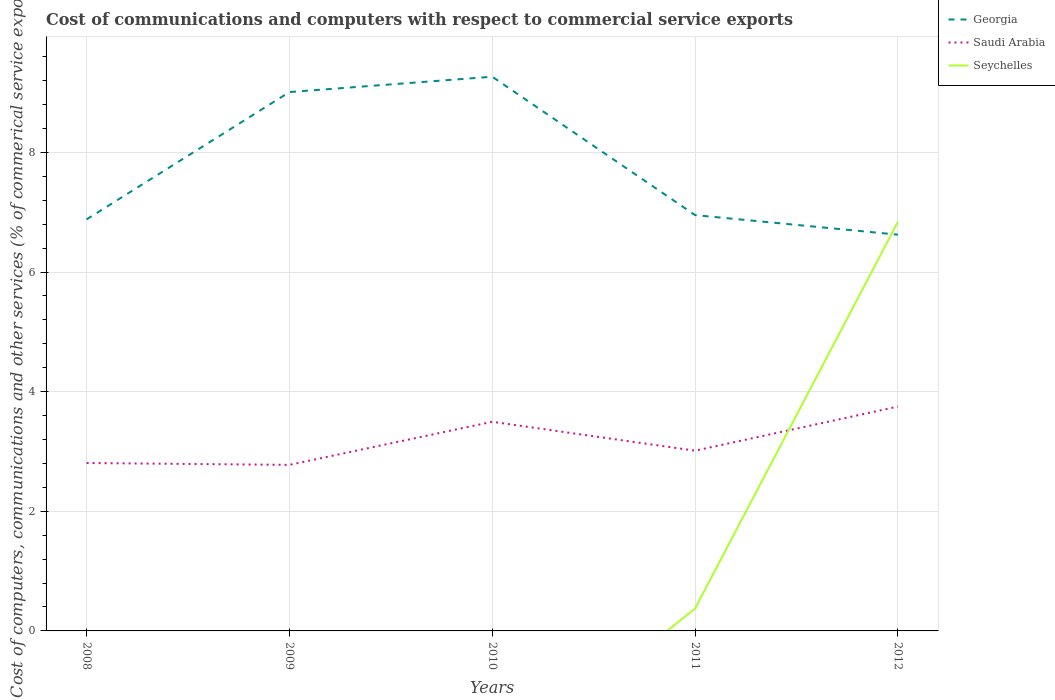How many different coloured lines are there?
Offer a very short reply. 3. Does the line corresponding to Georgia intersect with the line corresponding to Seychelles?
Make the answer very short. Yes. Is the number of lines equal to the number of legend labels?
Provide a short and direct response. No. What is the total cost of communications and computers in Georgia in the graph?
Ensure brevity in your answer.  -0.26. What is the difference between the highest and the second highest cost of communications and computers in Georgia?
Make the answer very short. 2.64. What is the difference between two consecutive major ticks on the Y-axis?
Make the answer very short. 2. Are the values on the major ticks of Y-axis written in scientific E-notation?
Make the answer very short. No. How many legend labels are there?
Provide a short and direct response. 3. How are the legend labels stacked?
Your response must be concise. Vertical. What is the title of the graph?
Your response must be concise. Cost of communications and computers with respect to commercial service exports. Does "Norway" appear as one of the legend labels in the graph?
Your answer should be compact. No. What is the label or title of the X-axis?
Keep it short and to the point. Years. What is the label or title of the Y-axis?
Make the answer very short. Cost of computers, communications and other services (% of commerical service exports). What is the Cost of computers, communications and other services (% of commerical service exports) of Georgia in 2008?
Make the answer very short. 6.88. What is the Cost of computers, communications and other services (% of commerical service exports) of Saudi Arabia in 2008?
Provide a short and direct response. 2.81. What is the Cost of computers, communications and other services (% of commerical service exports) in Georgia in 2009?
Provide a short and direct response. 9.01. What is the Cost of computers, communications and other services (% of commerical service exports) of Saudi Arabia in 2009?
Provide a short and direct response. 2.78. What is the Cost of computers, communications and other services (% of commerical service exports) in Seychelles in 2009?
Give a very brief answer. 0. What is the Cost of computers, communications and other services (% of commerical service exports) in Georgia in 2010?
Make the answer very short. 9.27. What is the Cost of computers, communications and other services (% of commerical service exports) of Saudi Arabia in 2010?
Ensure brevity in your answer.  3.5. What is the Cost of computers, communications and other services (% of commerical service exports) of Seychelles in 2010?
Offer a very short reply. 0. What is the Cost of computers, communications and other services (% of commerical service exports) in Georgia in 2011?
Give a very brief answer. 6.95. What is the Cost of computers, communications and other services (% of commerical service exports) in Saudi Arabia in 2011?
Your answer should be compact. 3.01. What is the Cost of computers, communications and other services (% of commerical service exports) in Seychelles in 2011?
Keep it short and to the point. 0.37. What is the Cost of computers, communications and other services (% of commerical service exports) in Georgia in 2012?
Your answer should be very brief. 6.62. What is the Cost of computers, communications and other services (% of commerical service exports) in Saudi Arabia in 2012?
Your response must be concise. 3.75. What is the Cost of computers, communications and other services (% of commerical service exports) of Seychelles in 2012?
Provide a short and direct response. 6.84. Across all years, what is the maximum Cost of computers, communications and other services (% of commerical service exports) of Georgia?
Your response must be concise. 9.27. Across all years, what is the maximum Cost of computers, communications and other services (% of commerical service exports) in Saudi Arabia?
Provide a short and direct response. 3.75. Across all years, what is the maximum Cost of computers, communications and other services (% of commerical service exports) in Seychelles?
Provide a short and direct response. 6.84. Across all years, what is the minimum Cost of computers, communications and other services (% of commerical service exports) in Georgia?
Your answer should be compact. 6.62. Across all years, what is the minimum Cost of computers, communications and other services (% of commerical service exports) in Saudi Arabia?
Your answer should be compact. 2.78. What is the total Cost of computers, communications and other services (% of commerical service exports) of Georgia in the graph?
Offer a terse response. 38.73. What is the total Cost of computers, communications and other services (% of commerical service exports) in Saudi Arabia in the graph?
Offer a terse response. 15.84. What is the total Cost of computers, communications and other services (% of commerical service exports) in Seychelles in the graph?
Make the answer very short. 7.21. What is the difference between the Cost of computers, communications and other services (% of commerical service exports) in Georgia in 2008 and that in 2009?
Your answer should be compact. -2.13. What is the difference between the Cost of computers, communications and other services (% of commerical service exports) of Saudi Arabia in 2008 and that in 2009?
Give a very brief answer. 0.03. What is the difference between the Cost of computers, communications and other services (% of commerical service exports) in Georgia in 2008 and that in 2010?
Give a very brief answer. -2.38. What is the difference between the Cost of computers, communications and other services (% of commerical service exports) of Saudi Arabia in 2008 and that in 2010?
Your answer should be very brief. -0.69. What is the difference between the Cost of computers, communications and other services (% of commerical service exports) in Georgia in 2008 and that in 2011?
Keep it short and to the point. -0.07. What is the difference between the Cost of computers, communications and other services (% of commerical service exports) in Saudi Arabia in 2008 and that in 2011?
Ensure brevity in your answer.  -0.21. What is the difference between the Cost of computers, communications and other services (% of commerical service exports) in Georgia in 2008 and that in 2012?
Offer a terse response. 0.26. What is the difference between the Cost of computers, communications and other services (% of commerical service exports) of Saudi Arabia in 2008 and that in 2012?
Ensure brevity in your answer.  -0.94. What is the difference between the Cost of computers, communications and other services (% of commerical service exports) of Georgia in 2009 and that in 2010?
Keep it short and to the point. -0.26. What is the difference between the Cost of computers, communications and other services (% of commerical service exports) in Saudi Arabia in 2009 and that in 2010?
Your answer should be compact. -0.72. What is the difference between the Cost of computers, communications and other services (% of commerical service exports) of Georgia in 2009 and that in 2011?
Your answer should be very brief. 2.06. What is the difference between the Cost of computers, communications and other services (% of commerical service exports) of Saudi Arabia in 2009 and that in 2011?
Keep it short and to the point. -0.24. What is the difference between the Cost of computers, communications and other services (% of commerical service exports) in Georgia in 2009 and that in 2012?
Your answer should be very brief. 2.38. What is the difference between the Cost of computers, communications and other services (% of commerical service exports) of Saudi Arabia in 2009 and that in 2012?
Ensure brevity in your answer.  -0.98. What is the difference between the Cost of computers, communications and other services (% of commerical service exports) in Georgia in 2010 and that in 2011?
Provide a short and direct response. 2.31. What is the difference between the Cost of computers, communications and other services (% of commerical service exports) in Saudi Arabia in 2010 and that in 2011?
Your response must be concise. 0.48. What is the difference between the Cost of computers, communications and other services (% of commerical service exports) in Georgia in 2010 and that in 2012?
Provide a short and direct response. 2.64. What is the difference between the Cost of computers, communications and other services (% of commerical service exports) in Saudi Arabia in 2010 and that in 2012?
Ensure brevity in your answer.  -0.25. What is the difference between the Cost of computers, communications and other services (% of commerical service exports) of Georgia in 2011 and that in 2012?
Provide a succinct answer. 0.33. What is the difference between the Cost of computers, communications and other services (% of commerical service exports) in Saudi Arabia in 2011 and that in 2012?
Keep it short and to the point. -0.74. What is the difference between the Cost of computers, communications and other services (% of commerical service exports) in Seychelles in 2011 and that in 2012?
Your response must be concise. -6.47. What is the difference between the Cost of computers, communications and other services (% of commerical service exports) of Georgia in 2008 and the Cost of computers, communications and other services (% of commerical service exports) of Saudi Arabia in 2009?
Your answer should be very brief. 4.1. What is the difference between the Cost of computers, communications and other services (% of commerical service exports) in Georgia in 2008 and the Cost of computers, communications and other services (% of commerical service exports) in Saudi Arabia in 2010?
Your response must be concise. 3.38. What is the difference between the Cost of computers, communications and other services (% of commerical service exports) in Georgia in 2008 and the Cost of computers, communications and other services (% of commerical service exports) in Saudi Arabia in 2011?
Offer a very short reply. 3.87. What is the difference between the Cost of computers, communications and other services (% of commerical service exports) of Georgia in 2008 and the Cost of computers, communications and other services (% of commerical service exports) of Seychelles in 2011?
Your answer should be compact. 6.51. What is the difference between the Cost of computers, communications and other services (% of commerical service exports) in Saudi Arabia in 2008 and the Cost of computers, communications and other services (% of commerical service exports) in Seychelles in 2011?
Provide a short and direct response. 2.43. What is the difference between the Cost of computers, communications and other services (% of commerical service exports) of Georgia in 2008 and the Cost of computers, communications and other services (% of commerical service exports) of Saudi Arabia in 2012?
Offer a very short reply. 3.13. What is the difference between the Cost of computers, communications and other services (% of commerical service exports) of Georgia in 2008 and the Cost of computers, communications and other services (% of commerical service exports) of Seychelles in 2012?
Ensure brevity in your answer.  0.04. What is the difference between the Cost of computers, communications and other services (% of commerical service exports) of Saudi Arabia in 2008 and the Cost of computers, communications and other services (% of commerical service exports) of Seychelles in 2012?
Offer a terse response. -4.03. What is the difference between the Cost of computers, communications and other services (% of commerical service exports) in Georgia in 2009 and the Cost of computers, communications and other services (% of commerical service exports) in Saudi Arabia in 2010?
Offer a very short reply. 5.51. What is the difference between the Cost of computers, communications and other services (% of commerical service exports) in Georgia in 2009 and the Cost of computers, communications and other services (% of commerical service exports) in Saudi Arabia in 2011?
Give a very brief answer. 6. What is the difference between the Cost of computers, communications and other services (% of commerical service exports) of Georgia in 2009 and the Cost of computers, communications and other services (% of commerical service exports) of Seychelles in 2011?
Provide a succinct answer. 8.63. What is the difference between the Cost of computers, communications and other services (% of commerical service exports) in Saudi Arabia in 2009 and the Cost of computers, communications and other services (% of commerical service exports) in Seychelles in 2011?
Keep it short and to the point. 2.4. What is the difference between the Cost of computers, communications and other services (% of commerical service exports) of Georgia in 2009 and the Cost of computers, communications and other services (% of commerical service exports) of Saudi Arabia in 2012?
Give a very brief answer. 5.26. What is the difference between the Cost of computers, communications and other services (% of commerical service exports) in Georgia in 2009 and the Cost of computers, communications and other services (% of commerical service exports) in Seychelles in 2012?
Give a very brief answer. 2.17. What is the difference between the Cost of computers, communications and other services (% of commerical service exports) of Saudi Arabia in 2009 and the Cost of computers, communications and other services (% of commerical service exports) of Seychelles in 2012?
Provide a succinct answer. -4.06. What is the difference between the Cost of computers, communications and other services (% of commerical service exports) in Georgia in 2010 and the Cost of computers, communications and other services (% of commerical service exports) in Saudi Arabia in 2011?
Provide a succinct answer. 6.25. What is the difference between the Cost of computers, communications and other services (% of commerical service exports) in Georgia in 2010 and the Cost of computers, communications and other services (% of commerical service exports) in Seychelles in 2011?
Keep it short and to the point. 8.89. What is the difference between the Cost of computers, communications and other services (% of commerical service exports) of Saudi Arabia in 2010 and the Cost of computers, communications and other services (% of commerical service exports) of Seychelles in 2011?
Keep it short and to the point. 3.12. What is the difference between the Cost of computers, communications and other services (% of commerical service exports) of Georgia in 2010 and the Cost of computers, communications and other services (% of commerical service exports) of Saudi Arabia in 2012?
Keep it short and to the point. 5.51. What is the difference between the Cost of computers, communications and other services (% of commerical service exports) in Georgia in 2010 and the Cost of computers, communications and other services (% of commerical service exports) in Seychelles in 2012?
Your response must be concise. 2.43. What is the difference between the Cost of computers, communications and other services (% of commerical service exports) in Saudi Arabia in 2010 and the Cost of computers, communications and other services (% of commerical service exports) in Seychelles in 2012?
Ensure brevity in your answer.  -3.34. What is the difference between the Cost of computers, communications and other services (% of commerical service exports) of Georgia in 2011 and the Cost of computers, communications and other services (% of commerical service exports) of Saudi Arabia in 2012?
Provide a short and direct response. 3.2. What is the difference between the Cost of computers, communications and other services (% of commerical service exports) in Georgia in 2011 and the Cost of computers, communications and other services (% of commerical service exports) in Seychelles in 2012?
Your answer should be very brief. 0.11. What is the difference between the Cost of computers, communications and other services (% of commerical service exports) in Saudi Arabia in 2011 and the Cost of computers, communications and other services (% of commerical service exports) in Seychelles in 2012?
Provide a succinct answer. -3.83. What is the average Cost of computers, communications and other services (% of commerical service exports) in Georgia per year?
Offer a terse response. 7.75. What is the average Cost of computers, communications and other services (% of commerical service exports) in Saudi Arabia per year?
Give a very brief answer. 3.17. What is the average Cost of computers, communications and other services (% of commerical service exports) in Seychelles per year?
Provide a succinct answer. 1.44. In the year 2008, what is the difference between the Cost of computers, communications and other services (% of commerical service exports) in Georgia and Cost of computers, communications and other services (% of commerical service exports) in Saudi Arabia?
Offer a terse response. 4.07. In the year 2009, what is the difference between the Cost of computers, communications and other services (% of commerical service exports) of Georgia and Cost of computers, communications and other services (% of commerical service exports) of Saudi Arabia?
Your answer should be very brief. 6.23. In the year 2010, what is the difference between the Cost of computers, communications and other services (% of commerical service exports) of Georgia and Cost of computers, communications and other services (% of commerical service exports) of Saudi Arabia?
Offer a very short reply. 5.77. In the year 2011, what is the difference between the Cost of computers, communications and other services (% of commerical service exports) in Georgia and Cost of computers, communications and other services (% of commerical service exports) in Saudi Arabia?
Offer a very short reply. 3.94. In the year 2011, what is the difference between the Cost of computers, communications and other services (% of commerical service exports) of Georgia and Cost of computers, communications and other services (% of commerical service exports) of Seychelles?
Provide a succinct answer. 6.58. In the year 2011, what is the difference between the Cost of computers, communications and other services (% of commerical service exports) in Saudi Arabia and Cost of computers, communications and other services (% of commerical service exports) in Seychelles?
Ensure brevity in your answer.  2.64. In the year 2012, what is the difference between the Cost of computers, communications and other services (% of commerical service exports) in Georgia and Cost of computers, communications and other services (% of commerical service exports) in Saudi Arabia?
Your response must be concise. 2.87. In the year 2012, what is the difference between the Cost of computers, communications and other services (% of commerical service exports) of Georgia and Cost of computers, communications and other services (% of commerical service exports) of Seychelles?
Your answer should be very brief. -0.22. In the year 2012, what is the difference between the Cost of computers, communications and other services (% of commerical service exports) in Saudi Arabia and Cost of computers, communications and other services (% of commerical service exports) in Seychelles?
Keep it short and to the point. -3.09. What is the ratio of the Cost of computers, communications and other services (% of commerical service exports) in Georgia in 2008 to that in 2009?
Your response must be concise. 0.76. What is the ratio of the Cost of computers, communications and other services (% of commerical service exports) of Saudi Arabia in 2008 to that in 2009?
Provide a short and direct response. 1.01. What is the ratio of the Cost of computers, communications and other services (% of commerical service exports) of Georgia in 2008 to that in 2010?
Ensure brevity in your answer.  0.74. What is the ratio of the Cost of computers, communications and other services (% of commerical service exports) in Saudi Arabia in 2008 to that in 2010?
Keep it short and to the point. 0.8. What is the ratio of the Cost of computers, communications and other services (% of commerical service exports) in Georgia in 2008 to that in 2011?
Offer a terse response. 0.99. What is the ratio of the Cost of computers, communications and other services (% of commerical service exports) of Saudi Arabia in 2008 to that in 2011?
Give a very brief answer. 0.93. What is the ratio of the Cost of computers, communications and other services (% of commerical service exports) of Georgia in 2008 to that in 2012?
Ensure brevity in your answer.  1.04. What is the ratio of the Cost of computers, communications and other services (% of commerical service exports) in Saudi Arabia in 2008 to that in 2012?
Provide a short and direct response. 0.75. What is the ratio of the Cost of computers, communications and other services (% of commerical service exports) in Georgia in 2009 to that in 2010?
Provide a succinct answer. 0.97. What is the ratio of the Cost of computers, communications and other services (% of commerical service exports) in Saudi Arabia in 2009 to that in 2010?
Your answer should be very brief. 0.79. What is the ratio of the Cost of computers, communications and other services (% of commerical service exports) in Georgia in 2009 to that in 2011?
Keep it short and to the point. 1.3. What is the ratio of the Cost of computers, communications and other services (% of commerical service exports) of Saudi Arabia in 2009 to that in 2011?
Your answer should be very brief. 0.92. What is the ratio of the Cost of computers, communications and other services (% of commerical service exports) in Georgia in 2009 to that in 2012?
Your answer should be compact. 1.36. What is the ratio of the Cost of computers, communications and other services (% of commerical service exports) of Saudi Arabia in 2009 to that in 2012?
Your response must be concise. 0.74. What is the ratio of the Cost of computers, communications and other services (% of commerical service exports) of Georgia in 2010 to that in 2011?
Your response must be concise. 1.33. What is the ratio of the Cost of computers, communications and other services (% of commerical service exports) of Saudi Arabia in 2010 to that in 2011?
Offer a terse response. 1.16. What is the ratio of the Cost of computers, communications and other services (% of commerical service exports) of Georgia in 2010 to that in 2012?
Offer a terse response. 1.4. What is the ratio of the Cost of computers, communications and other services (% of commerical service exports) of Saudi Arabia in 2010 to that in 2012?
Provide a short and direct response. 0.93. What is the ratio of the Cost of computers, communications and other services (% of commerical service exports) in Georgia in 2011 to that in 2012?
Keep it short and to the point. 1.05. What is the ratio of the Cost of computers, communications and other services (% of commerical service exports) of Saudi Arabia in 2011 to that in 2012?
Make the answer very short. 0.8. What is the ratio of the Cost of computers, communications and other services (% of commerical service exports) of Seychelles in 2011 to that in 2012?
Provide a short and direct response. 0.05. What is the difference between the highest and the second highest Cost of computers, communications and other services (% of commerical service exports) in Georgia?
Give a very brief answer. 0.26. What is the difference between the highest and the second highest Cost of computers, communications and other services (% of commerical service exports) in Saudi Arabia?
Keep it short and to the point. 0.25. What is the difference between the highest and the lowest Cost of computers, communications and other services (% of commerical service exports) in Georgia?
Your response must be concise. 2.64. What is the difference between the highest and the lowest Cost of computers, communications and other services (% of commerical service exports) in Saudi Arabia?
Make the answer very short. 0.98. What is the difference between the highest and the lowest Cost of computers, communications and other services (% of commerical service exports) in Seychelles?
Keep it short and to the point. 6.84. 